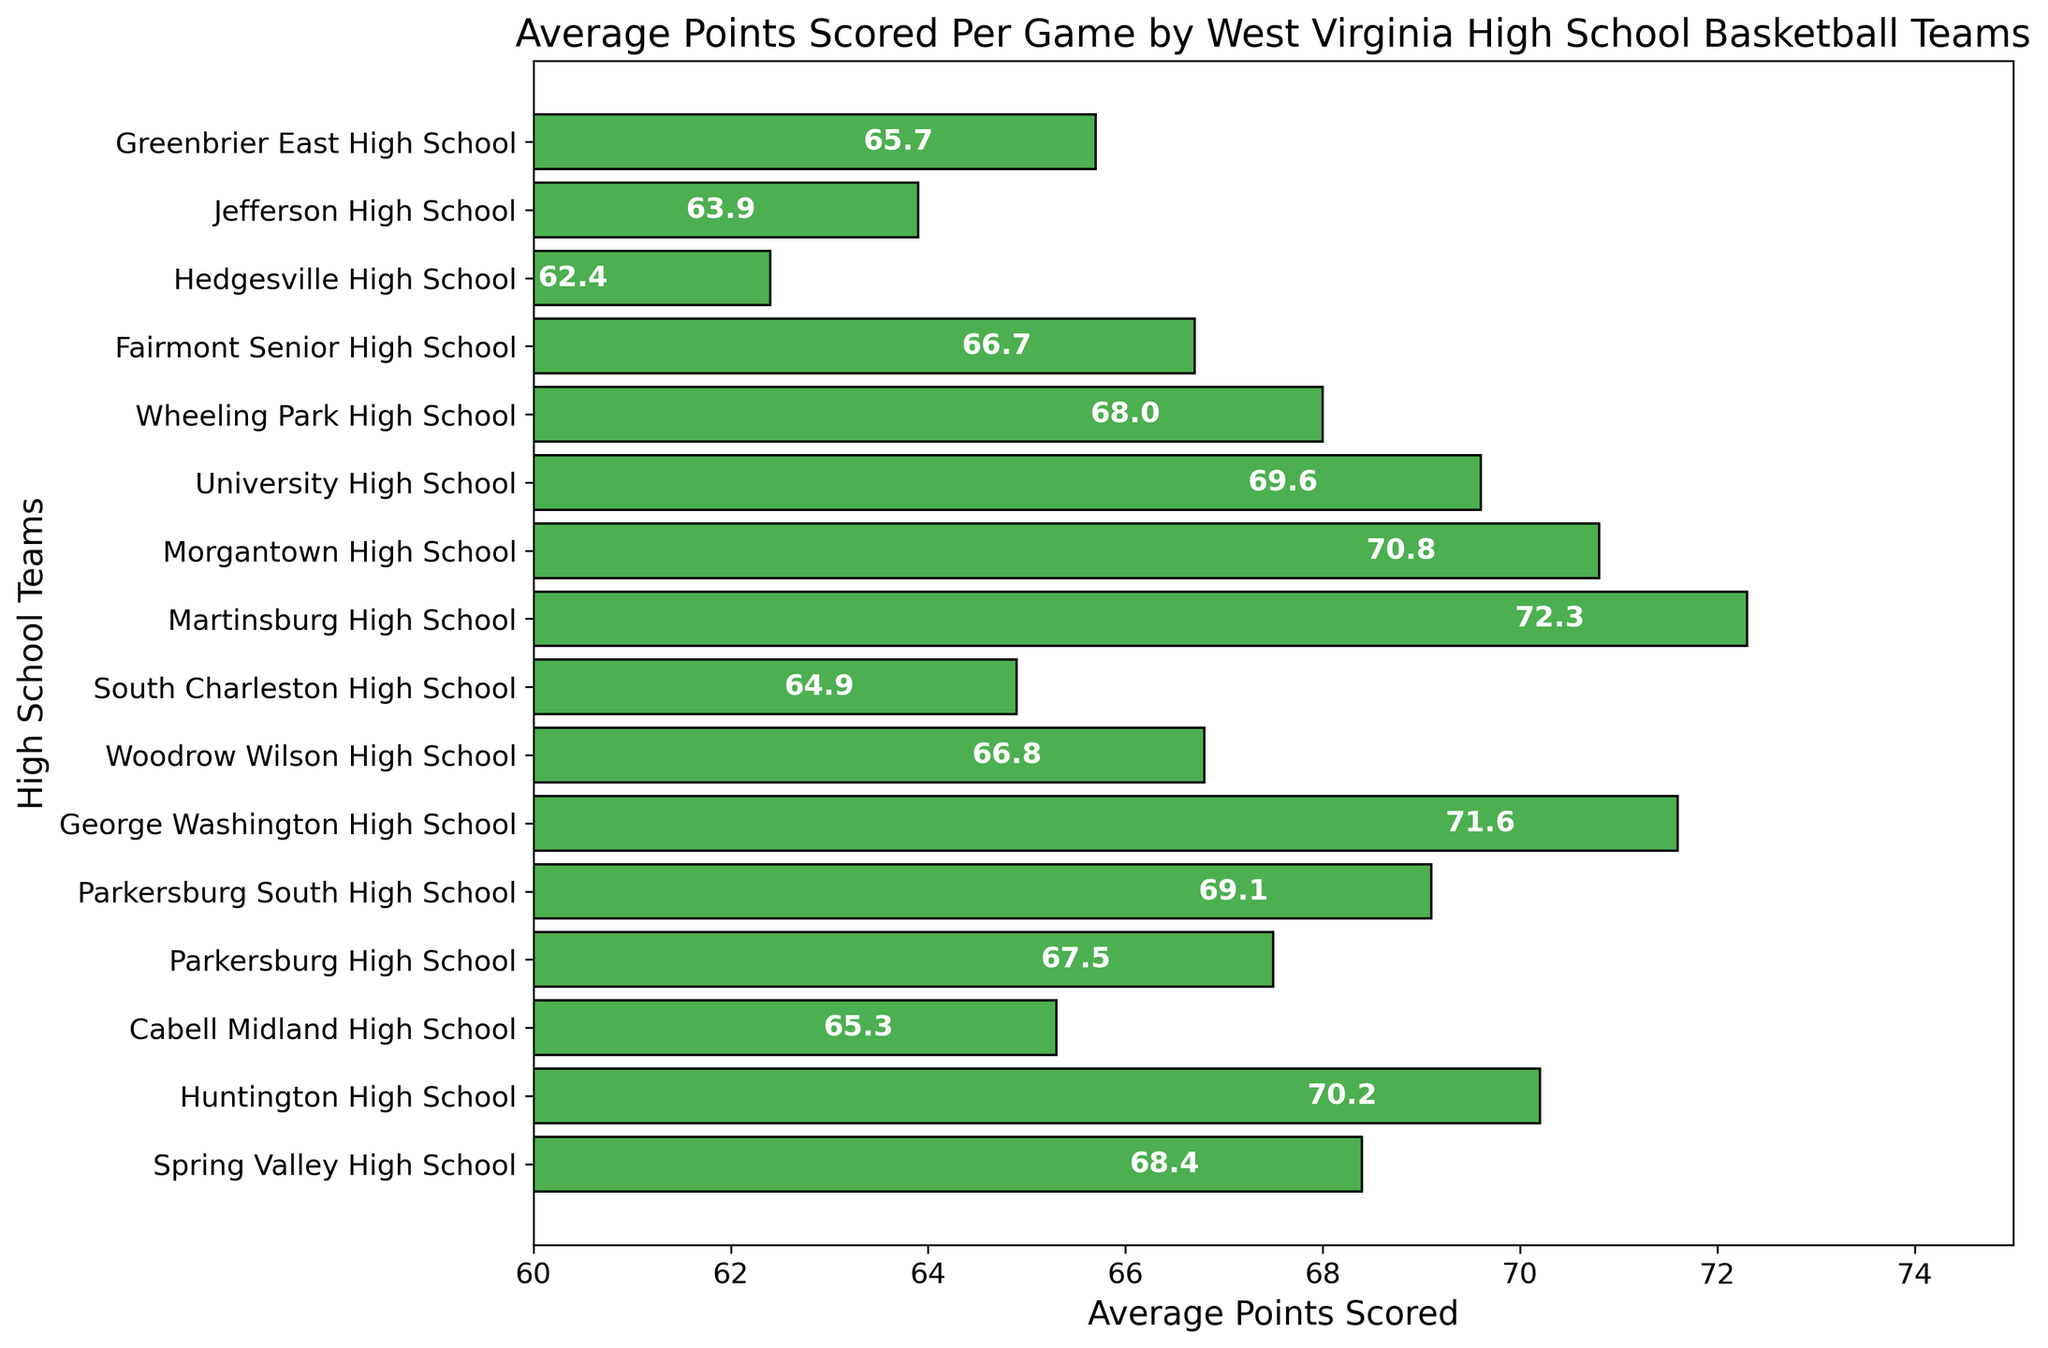Which team scored the highest average points per game? Find the bar with the greatest length in the horizontal direction, which represents the highest value. Here, Martinsburg High School has the longest bar at 72.3 points.
Answer: Martinsburg High School How much higher on average did Martinsburg High School score compared to Hedgesville High School? Subtract the average points of Hedgesville High School (62.4) from the average points of Martinsburg High School (72.3): 72.3 - 62.4 = 9.9
Answer: 9.9 Which team scored the lowest average points per game? Identify the bar with the shortest length in the horizontal direction, representing the lowest value. Hedgesville High School has the shortest bar at 62.4 points.
Answer: Hedgesville High School How do the average points of George Washington High School compare to Jefferson High School? Find both values and compare: George Washington High School scored 71.6, whereas Jefferson High School scored 63.9. George Washington High School scored more.
Answer: George Washington High School scored more What is the approximate average score of the top three scoring teams? Identify the top three bars with the highest values: Martinsburg (72.3), George Washington (71.6), Morgantown (70.8). Calculate the average: (72.3 + 71.6 + 70.8) / 3 ≈ 71.6
Answer: 71.6 What is the total average score for Cabell Midland High School and Spring Valley High School together? Sum the average points of both teams: 65.3 (Cabell Midland) + 68.4 (Spring Valley) = 133.7
Answer: 133.7 How many teams scored an average of 70 points or more? Count the bars with values 70 or more: Huntington (70.2), George Washington (71.6), Martinsburg (72.3), Morgantown (70.8), University (69.6, close but not 70). The count is 4.
Answer: 4 Between Fairmont Senior High School and Wheeling Park High School, which team had a higher average score and by how much? Compare the average points: Wheeling Park (68.0) and Fairmont Senior (66.7). Subtract the smaller from the larger: 68.0 - 66.7 = 1.3. Wheeling Park scored higher.
Answer: Wheeling Park by 1.3 What is the difference in average scores between the team with the highest score and the team with the lowest score? Subtract the average points of the lowest-scoring team (Hedgesville, 62.4) from the highest-scoring team (Martinsburg, 72.3): 72.3 - 62.4 = 9.9
Answer: 9.9 